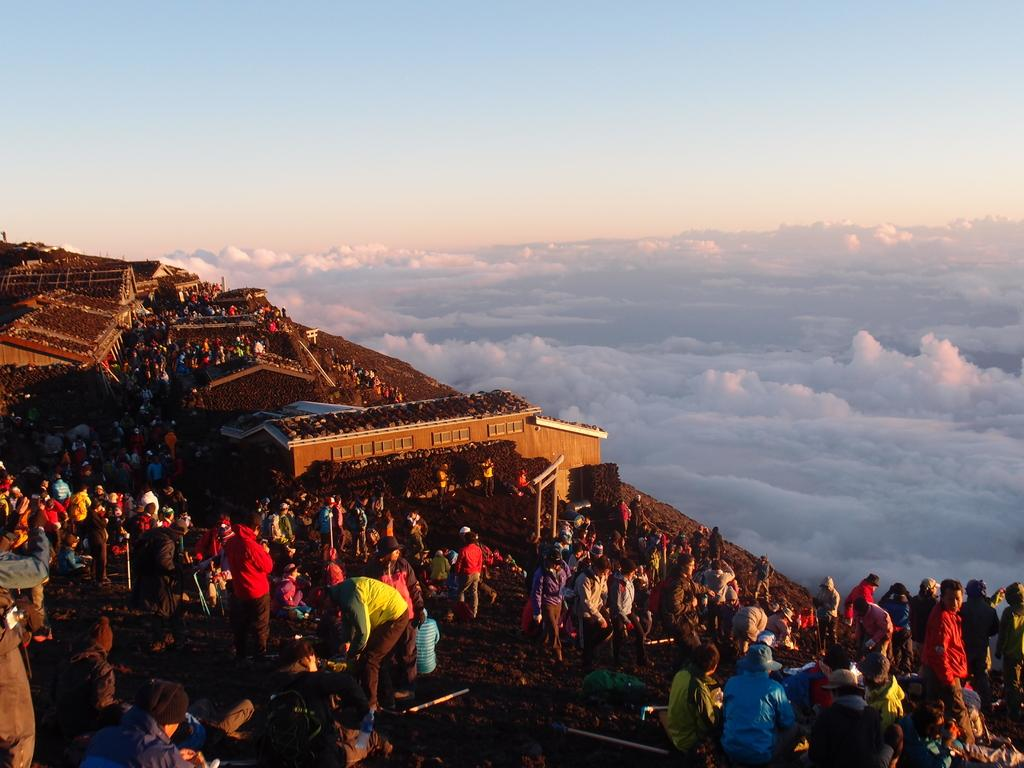Who or what can be seen in the image? There are people in the image. What type of structures are visible in the image? There are houses in the image. What architectural elements can be observed in the image? There are walls in the image. What is visible at the top of the image? The sky is visible at the top of the image. What type of branch is being used as a hat by one of the people in the image? There is no branch or hat present in the image; it only features people, houses, walls, and the sky. 